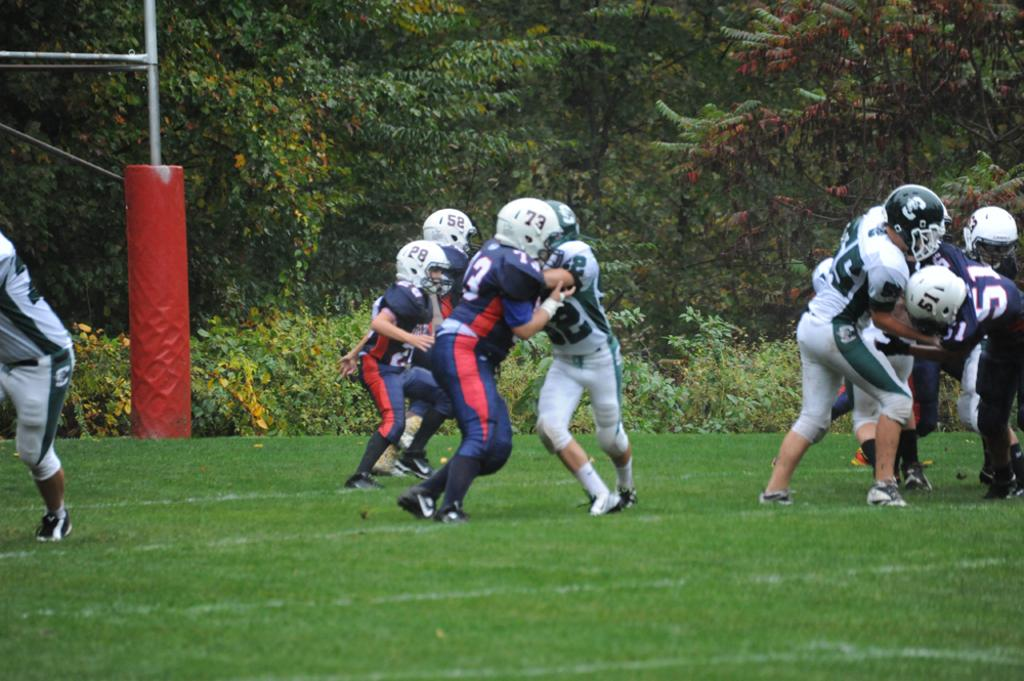How many people are in the image? There are people in the image, but the exact number is not specified. What are the people doing in the image? The people are playing a game in the image. What protective gear are the people wearing? The people are wearing helmets in the image. What type of terrain is visible at the bottom of the image? There is grass at the bottom of the image. What can be seen in the background of the image? There are trees in the background of the image. What object is present in the image that might be used for support or guidance? There is a pole in the image. How many eggs are being carried by the rabbits in the image? There are no rabbits or eggs present in the image. What is the stomach condition of the people in the image? There is no information about the stomach condition of the people in the image. 